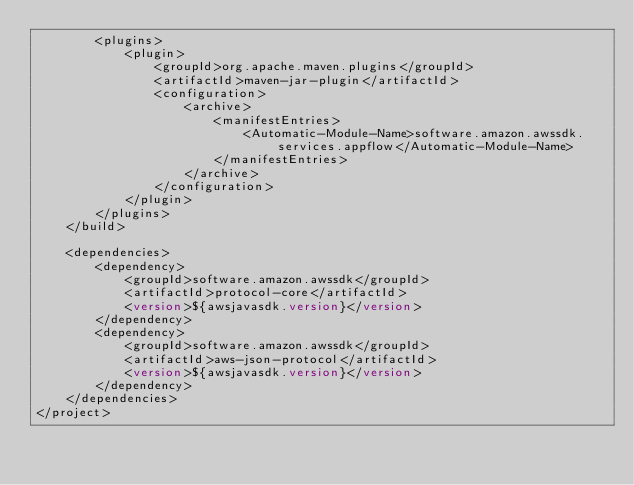<code> <loc_0><loc_0><loc_500><loc_500><_XML_>        <plugins>
            <plugin>
                <groupId>org.apache.maven.plugins</groupId>
                <artifactId>maven-jar-plugin</artifactId>
                <configuration>
                    <archive>
                        <manifestEntries>
                            <Automatic-Module-Name>software.amazon.awssdk.services.appflow</Automatic-Module-Name>
                        </manifestEntries>
                    </archive>
                </configuration>
            </plugin>
        </plugins>
    </build>

    <dependencies>
        <dependency>
            <groupId>software.amazon.awssdk</groupId>
            <artifactId>protocol-core</artifactId>
            <version>${awsjavasdk.version}</version>
        </dependency>
        <dependency>
            <groupId>software.amazon.awssdk</groupId>
            <artifactId>aws-json-protocol</artifactId>
            <version>${awsjavasdk.version}</version>
        </dependency>
    </dependencies>
</project>
</code> 